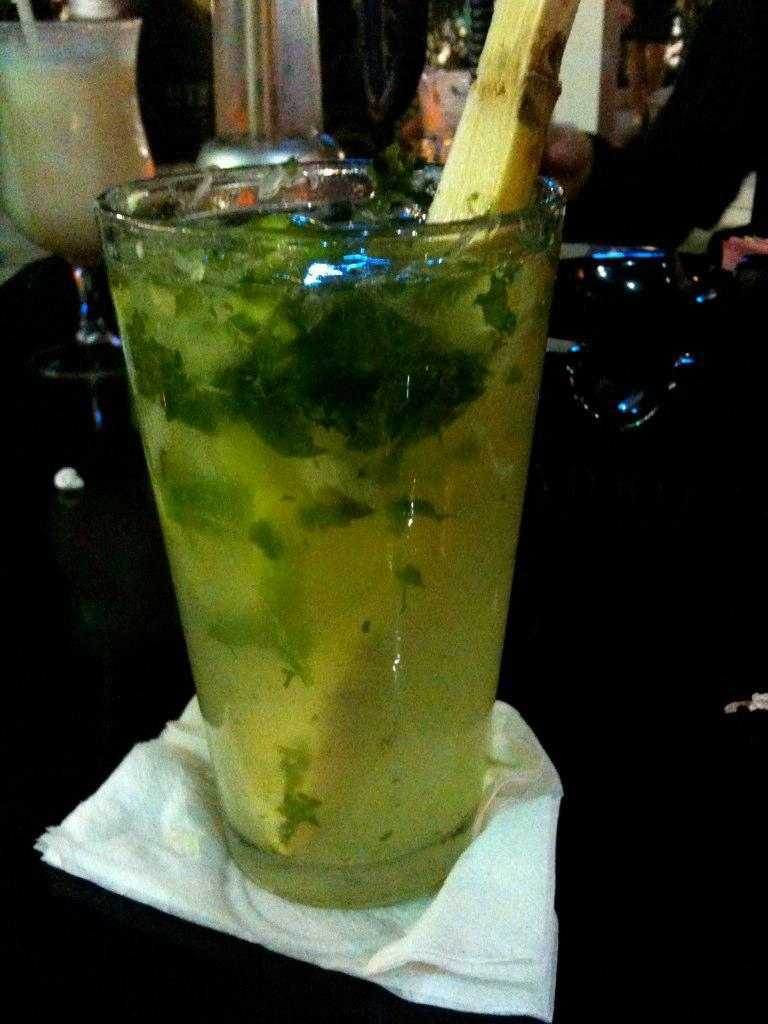What is on the table in the image? There is a glass, tissue paper, chopsticks, juice, milk, and mint leaves in the glass on the table. What is in the glass? There are mint leaves and water in the glass. What can be used for eating in the image? Chopsticks can be used for eating in the image. What are the two types of liquids on the table? Juice and milk are the two types of liquids on the table. What type of leather is visible on the table in the image? There is no leather present in the image. Can you describe the cat sitting on the table in the image? There is no cat present in the image. 